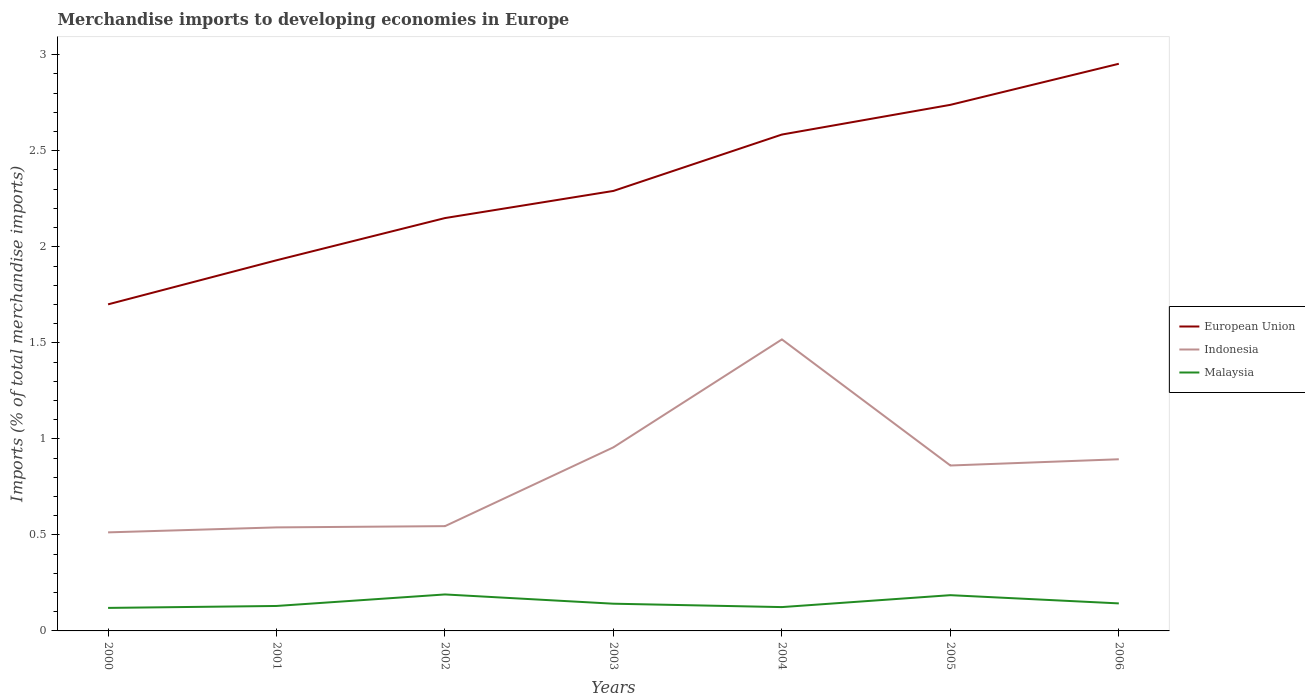How many different coloured lines are there?
Give a very brief answer. 3. Does the line corresponding to European Union intersect with the line corresponding to Malaysia?
Keep it short and to the point. No. Across all years, what is the maximum percentage total merchandise imports in European Union?
Provide a short and direct response. 1.7. In which year was the percentage total merchandise imports in Indonesia maximum?
Provide a short and direct response. 2000. What is the total percentage total merchandise imports in Malaysia in the graph?
Provide a short and direct response. -0. What is the difference between the highest and the second highest percentage total merchandise imports in Indonesia?
Your answer should be compact. 1. What is the difference between the highest and the lowest percentage total merchandise imports in European Union?
Provide a short and direct response. 3. How many lines are there?
Give a very brief answer. 3. How many years are there in the graph?
Make the answer very short. 7. Are the values on the major ticks of Y-axis written in scientific E-notation?
Offer a terse response. No. Does the graph contain any zero values?
Make the answer very short. No. Where does the legend appear in the graph?
Ensure brevity in your answer.  Center right. How are the legend labels stacked?
Keep it short and to the point. Vertical. What is the title of the graph?
Your answer should be very brief. Merchandise imports to developing economies in Europe. Does "Luxembourg" appear as one of the legend labels in the graph?
Provide a succinct answer. No. What is the label or title of the Y-axis?
Give a very brief answer. Imports (% of total merchandise imports). What is the Imports (% of total merchandise imports) of European Union in 2000?
Provide a succinct answer. 1.7. What is the Imports (% of total merchandise imports) of Indonesia in 2000?
Your answer should be very brief. 0.51. What is the Imports (% of total merchandise imports) in Malaysia in 2000?
Your answer should be very brief. 0.12. What is the Imports (% of total merchandise imports) of European Union in 2001?
Make the answer very short. 1.93. What is the Imports (% of total merchandise imports) of Indonesia in 2001?
Provide a short and direct response. 0.54. What is the Imports (% of total merchandise imports) of Malaysia in 2001?
Your response must be concise. 0.13. What is the Imports (% of total merchandise imports) of European Union in 2002?
Make the answer very short. 2.15. What is the Imports (% of total merchandise imports) in Indonesia in 2002?
Provide a short and direct response. 0.55. What is the Imports (% of total merchandise imports) in Malaysia in 2002?
Ensure brevity in your answer.  0.19. What is the Imports (% of total merchandise imports) in European Union in 2003?
Provide a short and direct response. 2.29. What is the Imports (% of total merchandise imports) of Indonesia in 2003?
Give a very brief answer. 0.96. What is the Imports (% of total merchandise imports) of Malaysia in 2003?
Ensure brevity in your answer.  0.14. What is the Imports (% of total merchandise imports) of European Union in 2004?
Give a very brief answer. 2.58. What is the Imports (% of total merchandise imports) in Indonesia in 2004?
Offer a very short reply. 1.52. What is the Imports (% of total merchandise imports) of Malaysia in 2004?
Offer a terse response. 0.12. What is the Imports (% of total merchandise imports) in European Union in 2005?
Your answer should be very brief. 2.74. What is the Imports (% of total merchandise imports) in Indonesia in 2005?
Provide a short and direct response. 0.86. What is the Imports (% of total merchandise imports) in Malaysia in 2005?
Ensure brevity in your answer.  0.19. What is the Imports (% of total merchandise imports) of European Union in 2006?
Make the answer very short. 2.95. What is the Imports (% of total merchandise imports) in Indonesia in 2006?
Your answer should be very brief. 0.89. What is the Imports (% of total merchandise imports) of Malaysia in 2006?
Ensure brevity in your answer.  0.14. Across all years, what is the maximum Imports (% of total merchandise imports) in European Union?
Your answer should be very brief. 2.95. Across all years, what is the maximum Imports (% of total merchandise imports) in Indonesia?
Give a very brief answer. 1.52. Across all years, what is the maximum Imports (% of total merchandise imports) of Malaysia?
Offer a very short reply. 0.19. Across all years, what is the minimum Imports (% of total merchandise imports) of European Union?
Give a very brief answer. 1.7. Across all years, what is the minimum Imports (% of total merchandise imports) in Indonesia?
Your answer should be compact. 0.51. Across all years, what is the minimum Imports (% of total merchandise imports) in Malaysia?
Give a very brief answer. 0.12. What is the total Imports (% of total merchandise imports) of European Union in the graph?
Your response must be concise. 16.35. What is the total Imports (% of total merchandise imports) of Indonesia in the graph?
Ensure brevity in your answer.  5.83. What is the total Imports (% of total merchandise imports) in Malaysia in the graph?
Give a very brief answer. 1.03. What is the difference between the Imports (% of total merchandise imports) in European Union in 2000 and that in 2001?
Your answer should be compact. -0.23. What is the difference between the Imports (% of total merchandise imports) of Indonesia in 2000 and that in 2001?
Provide a short and direct response. -0.03. What is the difference between the Imports (% of total merchandise imports) in Malaysia in 2000 and that in 2001?
Offer a very short reply. -0.01. What is the difference between the Imports (% of total merchandise imports) of European Union in 2000 and that in 2002?
Provide a succinct answer. -0.45. What is the difference between the Imports (% of total merchandise imports) of Indonesia in 2000 and that in 2002?
Your response must be concise. -0.03. What is the difference between the Imports (% of total merchandise imports) in Malaysia in 2000 and that in 2002?
Your answer should be very brief. -0.07. What is the difference between the Imports (% of total merchandise imports) in European Union in 2000 and that in 2003?
Offer a very short reply. -0.59. What is the difference between the Imports (% of total merchandise imports) in Indonesia in 2000 and that in 2003?
Ensure brevity in your answer.  -0.44. What is the difference between the Imports (% of total merchandise imports) of Malaysia in 2000 and that in 2003?
Make the answer very short. -0.02. What is the difference between the Imports (% of total merchandise imports) of European Union in 2000 and that in 2004?
Make the answer very short. -0.88. What is the difference between the Imports (% of total merchandise imports) of Indonesia in 2000 and that in 2004?
Ensure brevity in your answer.  -1. What is the difference between the Imports (% of total merchandise imports) of Malaysia in 2000 and that in 2004?
Your answer should be compact. -0. What is the difference between the Imports (% of total merchandise imports) of European Union in 2000 and that in 2005?
Make the answer very short. -1.04. What is the difference between the Imports (% of total merchandise imports) of Indonesia in 2000 and that in 2005?
Provide a short and direct response. -0.35. What is the difference between the Imports (% of total merchandise imports) of Malaysia in 2000 and that in 2005?
Offer a terse response. -0.07. What is the difference between the Imports (% of total merchandise imports) of European Union in 2000 and that in 2006?
Provide a succinct answer. -1.25. What is the difference between the Imports (% of total merchandise imports) in Indonesia in 2000 and that in 2006?
Ensure brevity in your answer.  -0.38. What is the difference between the Imports (% of total merchandise imports) of Malaysia in 2000 and that in 2006?
Give a very brief answer. -0.02. What is the difference between the Imports (% of total merchandise imports) of European Union in 2001 and that in 2002?
Ensure brevity in your answer.  -0.22. What is the difference between the Imports (% of total merchandise imports) of Indonesia in 2001 and that in 2002?
Offer a terse response. -0.01. What is the difference between the Imports (% of total merchandise imports) of Malaysia in 2001 and that in 2002?
Make the answer very short. -0.06. What is the difference between the Imports (% of total merchandise imports) in European Union in 2001 and that in 2003?
Ensure brevity in your answer.  -0.36. What is the difference between the Imports (% of total merchandise imports) of Indonesia in 2001 and that in 2003?
Offer a terse response. -0.42. What is the difference between the Imports (% of total merchandise imports) in Malaysia in 2001 and that in 2003?
Ensure brevity in your answer.  -0.01. What is the difference between the Imports (% of total merchandise imports) in European Union in 2001 and that in 2004?
Your answer should be very brief. -0.65. What is the difference between the Imports (% of total merchandise imports) of Indonesia in 2001 and that in 2004?
Give a very brief answer. -0.98. What is the difference between the Imports (% of total merchandise imports) of Malaysia in 2001 and that in 2004?
Offer a very short reply. 0.01. What is the difference between the Imports (% of total merchandise imports) in European Union in 2001 and that in 2005?
Offer a terse response. -0.81. What is the difference between the Imports (% of total merchandise imports) in Indonesia in 2001 and that in 2005?
Offer a very short reply. -0.32. What is the difference between the Imports (% of total merchandise imports) in Malaysia in 2001 and that in 2005?
Provide a succinct answer. -0.06. What is the difference between the Imports (% of total merchandise imports) of European Union in 2001 and that in 2006?
Offer a terse response. -1.02. What is the difference between the Imports (% of total merchandise imports) of Indonesia in 2001 and that in 2006?
Keep it short and to the point. -0.35. What is the difference between the Imports (% of total merchandise imports) of Malaysia in 2001 and that in 2006?
Offer a terse response. -0.01. What is the difference between the Imports (% of total merchandise imports) of European Union in 2002 and that in 2003?
Your response must be concise. -0.14. What is the difference between the Imports (% of total merchandise imports) of Indonesia in 2002 and that in 2003?
Provide a succinct answer. -0.41. What is the difference between the Imports (% of total merchandise imports) in Malaysia in 2002 and that in 2003?
Keep it short and to the point. 0.05. What is the difference between the Imports (% of total merchandise imports) in European Union in 2002 and that in 2004?
Your answer should be very brief. -0.43. What is the difference between the Imports (% of total merchandise imports) of Indonesia in 2002 and that in 2004?
Provide a succinct answer. -0.97. What is the difference between the Imports (% of total merchandise imports) in Malaysia in 2002 and that in 2004?
Ensure brevity in your answer.  0.07. What is the difference between the Imports (% of total merchandise imports) of European Union in 2002 and that in 2005?
Your response must be concise. -0.59. What is the difference between the Imports (% of total merchandise imports) in Indonesia in 2002 and that in 2005?
Ensure brevity in your answer.  -0.32. What is the difference between the Imports (% of total merchandise imports) of Malaysia in 2002 and that in 2005?
Your answer should be compact. 0. What is the difference between the Imports (% of total merchandise imports) of European Union in 2002 and that in 2006?
Your response must be concise. -0.8. What is the difference between the Imports (% of total merchandise imports) of Indonesia in 2002 and that in 2006?
Offer a very short reply. -0.35. What is the difference between the Imports (% of total merchandise imports) of Malaysia in 2002 and that in 2006?
Offer a very short reply. 0.05. What is the difference between the Imports (% of total merchandise imports) of European Union in 2003 and that in 2004?
Offer a very short reply. -0.29. What is the difference between the Imports (% of total merchandise imports) of Indonesia in 2003 and that in 2004?
Your response must be concise. -0.56. What is the difference between the Imports (% of total merchandise imports) of Malaysia in 2003 and that in 2004?
Ensure brevity in your answer.  0.02. What is the difference between the Imports (% of total merchandise imports) in European Union in 2003 and that in 2005?
Offer a very short reply. -0.45. What is the difference between the Imports (% of total merchandise imports) of Indonesia in 2003 and that in 2005?
Offer a terse response. 0.09. What is the difference between the Imports (% of total merchandise imports) in Malaysia in 2003 and that in 2005?
Keep it short and to the point. -0.04. What is the difference between the Imports (% of total merchandise imports) in European Union in 2003 and that in 2006?
Provide a succinct answer. -0.66. What is the difference between the Imports (% of total merchandise imports) in Indonesia in 2003 and that in 2006?
Give a very brief answer. 0.06. What is the difference between the Imports (% of total merchandise imports) of Malaysia in 2003 and that in 2006?
Keep it short and to the point. -0. What is the difference between the Imports (% of total merchandise imports) of European Union in 2004 and that in 2005?
Offer a very short reply. -0.15. What is the difference between the Imports (% of total merchandise imports) of Indonesia in 2004 and that in 2005?
Your answer should be compact. 0.66. What is the difference between the Imports (% of total merchandise imports) of Malaysia in 2004 and that in 2005?
Offer a very short reply. -0.06. What is the difference between the Imports (% of total merchandise imports) in European Union in 2004 and that in 2006?
Offer a terse response. -0.37. What is the difference between the Imports (% of total merchandise imports) of Indonesia in 2004 and that in 2006?
Offer a terse response. 0.62. What is the difference between the Imports (% of total merchandise imports) of Malaysia in 2004 and that in 2006?
Give a very brief answer. -0.02. What is the difference between the Imports (% of total merchandise imports) in European Union in 2005 and that in 2006?
Keep it short and to the point. -0.21. What is the difference between the Imports (% of total merchandise imports) in Indonesia in 2005 and that in 2006?
Your answer should be very brief. -0.03. What is the difference between the Imports (% of total merchandise imports) of Malaysia in 2005 and that in 2006?
Your response must be concise. 0.04. What is the difference between the Imports (% of total merchandise imports) of European Union in 2000 and the Imports (% of total merchandise imports) of Indonesia in 2001?
Ensure brevity in your answer.  1.16. What is the difference between the Imports (% of total merchandise imports) of European Union in 2000 and the Imports (% of total merchandise imports) of Malaysia in 2001?
Offer a very short reply. 1.57. What is the difference between the Imports (% of total merchandise imports) of Indonesia in 2000 and the Imports (% of total merchandise imports) of Malaysia in 2001?
Your answer should be very brief. 0.38. What is the difference between the Imports (% of total merchandise imports) of European Union in 2000 and the Imports (% of total merchandise imports) of Indonesia in 2002?
Offer a terse response. 1.15. What is the difference between the Imports (% of total merchandise imports) of European Union in 2000 and the Imports (% of total merchandise imports) of Malaysia in 2002?
Your response must be concise. 1.51. What is the difference between the Imports (% of total merchandise imports) in Indonesia in 2000 and the Imports (% of total merchandise imports) in Malaysia in 2002?
Provide a succinct answer. 0.32. What is the difference between the Imports (% of total merchandise imports) in European Union in 2000 and the Imports (% of total merchandise imports) in Indonesia in 2003?
Your response must be concise. 0.74. What is the difference between the Imports (% of total merchandise imports) in European Union in 2000 and the Imports (% of total merchandise imports) in Malaysia in 2003?
Your response must be concise. 1.56. What is the difference between the Imports (% of total merchandise imports) in Indonesia in 2000 and the Imports (% of total merchandise imports) in Malaysia in 2003?
Your answer should be very brief. 0.37. What is the difference between the Imports (% of total merchandise imports) of European Union in 2000 and the Imports (% of total merchandise imports) of Indonesia in 2004?
Your answer should be very brief. 0.18. What is the difference between the Imports (% of total merchandise imports) of European Union in 2000 and the Imports (% of total merchandise imports) of Malaysia in 2004?
Offer a very short reply. 1.58. What is the difference between the Imports (% of total merchandise imports) of Indonesia in 2000 and the Imports (% of total merchandise imports) of Malaysia in 2004?
Offer a terse response. 0.39. What is the difference between the Imports (% of total merchandise imports) of European Union in 2000 and the Imports (% of total merchandise imports) of Indonesia in 2005?
Offer a terse response. 0.84. What is the difference between the Imports (% of total merchandise imports) in European Union in 2000 and the Imports (% of total merchandise imports) in Malaysia in 2005?
Your response must be concise. 1.51. What is the difference between the Imports (% of total merchandise imports) in Indonesia in 2000 and the Imports (% of total merchandise imports) in Malaysia in 2005?
Your answer should be very brief. 0.33. What is the difference between the Imports (% of total merchandise imports) in European Union in 2000 and the Imports (% of total merchandise imports) in Indonesia in 2006?
Your response must be concise. 0.81. What is the difference between the Imports (% of total merchandise imports) of European Union in 2000 and the Imports (% of total merchandise imports) of Malaysia in 2006?
Give a very brief answer. 1.56. What is the difference between the Imports (% of total merchandise imports) of Indonesia in 2000 and the Imports (% of total merchandise imports) of Malaysia in 2006?
Provide a succinct answer. 0.37. What is the difference between the Imports (% of total merchandise imports) of European Union in 2001 and the Imports (% of total merchandise imports) of Indonesia in 2002?
Ensure brevity in your answer.  1.38. What is the difference between the Imports (% of total merchandise imports) in European Union in 2001 and the Imports (% of total merchandise imports) in Malaysia in 2002?
Give a very brief answer. 1.74. What is the difference between the Imports (% of total merchandise imports) in Indonesia in 2001 and the Imports (% of total merchandise imports) in Malaysia in 2002?
Your response must be concise. 0.35. What is the difference between the Imports (% of total merchandise imports) in European Union in 2001 and the Imports (% of total merchandise imports) in Indonesia in 2003?
Your answer should be compact. 0.97. What is the difference between the Imports (% of total merchandise imports) of European Union in 2001 and the Imports (% of total merchandise imports) of Malaysia in 2003?
Your response must be concise. 1.79. What is the difference between the Imports (% of total merchandise imports) of Indonesia in 2001 and the Imports (% of total merchandise imports) of Malaysia in 2003?
Your answer should be compact. 0.4. What is the difference between the Imports (% of total merchandise imports) of European Union in 2001 and the Imports (% of total merchandise imports) of Indonesia in 2004?
Keep it short and to the point. 0.41. What is the difference between the Imports (% of total merchandise imports) of European Union in 2001 and the Imports (% of total merchandise imports) of Malaysia in 2004?
Ensure brevity in your answer.  1.81. What is the difference between the Imports (% of total merchandise imports) of Indonesia in 2001 and the Imports (% of total merchandise imports) of Malaysia in 2004?
Your answer should be very brief. 0.41. What is the difference between the Imports (% of total merchandise imports) of European Union in 2001 and the Imports (% of total merchandise imports) of Indonesia in 2005?
Keep it short and to the point. 1.07. What is the difference between the Imports (% of total merchandise imports) of European Union in 2001 and the Imports (% of total merchandise imports) of Malaysia in 2005?
Keep it short and to the point. 1.74. What is the difference between the Imports (% of total merchandise imports) of Indonesia in 2001 and the Imports (% of total merchandise imports) of Malaysia in 2005?
Ensure brevity in your answer.  0.35. What is the difference between the Imports (% of total merchandise imports) of European Union in 2001 and the Imports (% of total merchandise imports) of Indonesia in 2006?
Your response must be concise. 1.04. What is the difference between the Imports (% of total merchandise imports) of European Union in 2001 and the Imports (% of total merchandise imports) of Malaysia in 2006?
Your answer should be compact. 1.79. What is the difference between the Imports (% of total merchandise imports) in Indonesia in 2001 and the Imports (% of total merchandise imports) in Malaysia in 2006?
Your answer should be very brief. 0.4. What is the difference between the Imports (% of total merchandise imports) in European Union in 2002 and the Imports (% of total merchandise imports) in Indonesia in 2003?
Make the answer very short. 1.19. What is the difference between the Imports (% of total merchandise imports) in European Union in 2002 and the Imports (% of total merchandise imports) in Malaysia in 2003?
Make the answer very short. 2.01. What is the difference between the Imports (% of total merchandise imports) in Indonesia in 2002 and the Imports (% of total merchandise imports) in Malaysia in 2003?
Provide a succinct answer. 0.4. What is the difference between the Imports (% of total merchandise imports) in European Union in 2002 and the Imports (% of total merchandise imports) in Indonesia in 2004?
Provide a succinct answer. 0.63. What is the difference between the Imports (% of total merchandise imports) of European Union in 2002 and the Imports (% of total merchandise imports) of Malaysia in 2004?
Offer a very short reply. 2.03. What is the difference between the Imports (% of total merchandise imports) of Indonesia in 2002 and the Imports (% of total merchandise imports) of Malaysia in 2004?
Give a very brief answer. 0.42. What is the difference between the Imports (% of total merchandise imports) of European Union in 2002 and the Imports (% of total merchandise imports) of Indonesia in 2005?
Provide a succinct answer. 1.29. What is the difference between the Imports (% of total merchandise imports) in European Union in 2002 and the Imports (% of total merchandise imports) in Malaysia in 2005?
Your response must be concise. 1.96. What is the difference between the Imports (% of total merchandise imports) in Indonesia in 2002 and the Imports (% of total merchandise imports) in Malaysia in 2005?
Provide a short and direct response. 0.36. What is the difference between the Imports (% of total merchandise imports) of European Union in 2002 and the Imports (% of total merchandise imports) of Indonesia in 2006?
Provide a succinct answer. 1.26. What is the difference between the Imports (% of total merchandise imports) in European Union in 2002 and the Imports (% of total merchandise imports) in Malaysia in 2006?
Offer a terse response. 2.01. What is the difference between the Imports (% of total merchandise imports) of Indonesia in 2002 and the Imports (% of total merchandise imports) of Malaysia in 2006?
Make the answer very short. 0.4. What is the difference between the Imports (% of total merchandise imports) in European Union in 2003 and the Imports (% of total merchandise imports) in Indonesia in 2004?
Offer a terse response. 0.77. What is the difference between the Imports (% of total merchandise imports) of European Union in 2003 and the Imports (% of total merchandise imports) of Malaysia in 2004?
Make the answer very short. 2.17. What is the difference between the Imports (% of total merchandise imports) of Indonesia in 2003 and the Imports (% of total merchandise imports) of Malaysia in 2004?
Your response must be concise. 0.83. What is the difference between the Imports (% of total merchandise imports) in European Union in 2003 and the Imports (% of total merchandise imports) in Indonesia in 2005?
Provide a short and direct response. 1.43. What is the difference between the Imports (% of total merchandise imports) of European Union in 2003 and the Imports (% of total merchandise imports) of Malaysia in 2005?
Your response must be concise. 2.1. What is the difference between the Imports (% of total merchandise imports) in Indonesia in 2003 and the Imports (% of total merchandise imports) in Malaysia in 2005?
Keep it short and to the point. 0.77. What is the difference between the Imports (% of total merchandise imports) of European Union in 2003 and the Imports (% of total merchandise imports) of Indonesia in 2006?
Provide a short and direct response. 1.4. What is the difference between the Imports (% of total merchandise imports) of European Union in 2003 and the Imports (% of total merchandise imports) of Malaysia in 2006?
Your response must be concise. 2.15. What is the difference between the Imports (% of total merchandise imports) in Indonesia in 2003 and the Imports (% of total merchandise imports) in Malaysia in 2006?
Provide a short and direct response. 0.81. What is the difference between the Imports (% of total merchandise imports) of European Union in 2004 and the Imports (% of total merchandise imports) of Indonesia in 2005?
Your answer should be compact. 1.72. What is the difference between the Imports (% of total merchandise imports) in European Union in 2004 and the Imports (% of total merchandise imports) in Malaysia in 2005?
Your answer should be compact. 2.4. What is the difference between the Imports (% of total merchandise imports) in Indonesia in 2004 and the Imports (% of total merchandise imports) in Malaysia in 2005?
Offer a very short reply. 1.33. What is the difference between the Imports (% of total merchandise imports) of European Union in 2004 and the Imports (% of total merchandise imports) of Indonesia in 2006?
Your response must be concise. 1.69. What is the difference between the Imports (% of total merchandise imports) of European Union in 2004 and the Imports (% of total merchandise imports) of Malaysia in 2006?
Keep it short and to the point. 2.44. What is the difference between the Imports (% of total merchandise imports) of Indonesia in 2004 and the Imports (% of total merchandise imports) of Malaysia in 2006?
Provide a short and direct response. 1.37. What is the difference between the Imports (% of total merchandise imports) in European Union in 2005 and the Imports (% of total merchandise imports) in Indonesia in 2006?
Ensure brevity in your answer.  1.85. What is the difference between the Imports (% of total merchandise imports) in European Union in 2005 and the Imports (% of total merchandise imports) in Malaysia in 2006?
Offer a very short reply. 2.6. What is the difference between the Imports (% of total merchandise imports) of Indonesia in 2005 and the Imports (% of total merchandise imports) of Malaysia in 2006?
Offer a very short reply. 0.72. What is the average Imports (% of total merchandise imports) in European Union per year?
Keep it short and to the point. 2.34. What is the average Imports (% of total merchandise imports) of Indonesia per year?
Your answer should be compact. 0.83. What is the average Imports (% of total merchandise imports) of Malaysia per year?
Provide a succinct answer. 0.15. In the year 2000, what is the difference between the Imports (% of total merchandise imports) in European Union and Imports (% of total merchandise imports) in Indonesia?
Offer a very short reply. 1.19. In the year 2000, what is the difference between the Imports (% of total merchandise imports) in European Union and Imports (% of total merchandise imports) in Malaysia?
Offer a terse response. 1.58. In the year 2000, what is the difference between the Imports (% of total merchandise imports) of Indonesia and Imports (% of total merchandise imports) of Malaysia?
Ensure brevity in your answer.  0.39. In the year 2001, what is the difference between the Imports (% of total merchandise imports) in European Union and Imports (% of total merchandise imports) in Indonesia?
Give a very brief answer. 1.39. In the year 2001, what is the difference between the Imports (% of total merchandise imports) of European Union and Imports (% of total merchandise imports) of Malaysia?
Your response must be concise. 1.8. In the year 2001, what is the difference between the Imports (% of total merchandise imports) of Indonesia and Imports (% of total merchandise imports) of Malaysia?
Give a very brief answer. 0.41. In the year 2002, what is the difference between the Imports (% of total merchandise imports) of European Union and Imports (% of total merchandise imports) of Indonesia?
Your answer should be compact. 1.6. In the year 2002, what is the difference between the Imports (% of total merchandise imports) of European Union and Imports (% of total merchandise imports) of Malaysia?
Your answer should be compact. 1.96. In the year 2002, what is the difference between the Imports (% of total merchandise imports) in Indonesia and Imports (% of total merchandise imports) in Malaysia?
Your answer should be very brief. 0.36. In the year 2003, what is the difference between the Imports (% of total merchandise imports) of European Union and Imports (% of total merchandise imports) of Indonesia?
Your answer should be very brief. 1.33. In the year 2003, what is the difference between the Imports (% of total merchandise imports) in European Union and Imports (% of total merchandise imports) in Malaysia?
Offer a very short reply. 2.15. In the year 2003, what is the difference between the Imports (% of total merchandise imports) of Indonesia and Imports (% of total merchandise imports) of Malaysia?
Offer a very short reply. 0.81. In the year 2004, what is the difference between the Imports (% of total merchandise imports) of European Union and Imports (% of total merchandise imports) of Indonesia?
Make the answer very short. 1.07. In the year 2004, what is the difference between the Imports (% of total merchandise imports) in European Union and Imports (% of total merchandise imports) in Malaysia?
Ensure brevity in your answer.  2.46. In the year 2004, what is the difference between the Imports (% of total merchandise imports) of Indonesia and Imports (% of total merchandise imports) of Malaysia?
Your answer should be compact. 1.39. In the year 2005, what is the difference between the Imports (% of total merchandise imports) of European Union and Imports (% of total merchandise imports) of Indonesia?
Provide a succinct answer. 1.88. In the year 2005, what is the difference between the Imports (% of total merchandise imports) in European Union and Imports (% of total merchandise imports) in Malaysia?
Offer a very short reply. 2.55. In the year 2005, what is the difference between the Imports (% of total merchandise imports) in Indonesia and Imports (% of total merchandise imports) in Malaysia?
Your response must be concise. 0.68. In the year 2006, what is the difference between the Imports (% of total merchandise imports) in European Union and Imports (% of total merchandise imports) in Indonesia?
Your answer should be compact. 2.06. In the year 2006, what is the difference between the Imports (% of total merchandise imports) of European Union and Imports (% of total merchandise imports) of Malaysia?
Offer a very short reply. 2.81. In the year 2006, what is the difference between the Imports (% of total merchandise imports) in Indonesia and Imports (% of total merchandise imports) in Malaysia?
Make the answer very short. 0.75. What is the ratio of the Imports (% of total merchandise imports) of European Union in 2000 to that in 2001?
Give a very brief answer. 0.88. What is the ratio of the Imports (% of total merchandise imports) of Malaysia in 2000 to that in 2001?
Keep it short and to the point. 0.92. What is the ratio of the Imports (% of total merchandise imports) in European Union in 2000 to that in 2002?
Your answer should be very brief. 0.79. What is the ratio of the Imports (% of total merchandise imports) of Indonesia in 2000 to that in 2002?
Offer a terse response. 0.94. What is the ratio of the Imports (% of total merchandise imports) of Malaysia in 2000 to that in 2002?
Your answer should be compact. 0.63. What is the ratio of the Imports (% of total merchandise imports) in European Union in 2000 to that in 2003?
Provide a succinct answer. 0.74. What is the ratio of the Imports (% of total merchandise imports) of Indonesia in 2000 to that in 2003?
Your answer should be compact. 0.54. What is the ratio of the Imports (% of total merchandise imports) in Malaysia in 2000 to that in 2003?
Provide a succinct answer. 0.85. What is the ratio of the Imports (% of total merchandise imports) of European Union in 2000 to that in 2004?
Your response must be concise. 0.66. What is the ratio of the Imports (% of total merchandise imports) in Indonesia in 2000 to that in 2004?
Give a very brief answer. 0.34. What is the ratio of the Imports (% of total merchandise imports) of Malaysia in 2000 to that in 2004?
Your response must be concise. 0.97. What is the ratio of the Imports (% of total merchandise imports) in European Union in 2000 to that in 2005?
Keep it short and to the point. 0.62. What is the ratio of the Imports (% of total merchandise imports) of Indonesia in 2000 to that in 2005?
Offer a very short reply. 0.6. What is the ratio of the Imports (% of total merchandise imports) of Malaysia in 2000 to that in 2005?
Provide a succinct answer. 0.64. What is the ratio of the Imports (% of total merchandise imports) of European Union in 2000 to that in 2006?
Your response must be concise. 0.58. What is the ratio of the Imports (% of total merchandise imports) in Indonesia in 2000 to that in 2006?
Provide a succinct answer. 0.57. What is the ratio of the Imports (% of total merchandise imports) in Malaysia in 2000 to that in 2006?
Give a very brief answer. 0.84. What is the ratio of the Imports (% of total merchandise imports) of European Union in 2001 to that in 2002?
Make the answer very short. 0.9. What is the ratio of the Imports (% of total merchandise imports) in Malaysia in 2001 to that in 2002?
Keep it short and to the point. 0.68. What is the ratio of the Imports (% of total merchandise imports) in European Union in 2001 to that in 2003?
Your response must be concise. 0.84. What is the ratio of the Imports (% of total merchandise imports) of Indonesia in 2001 to that in 2003?
Keep it short and to the point. 0.56. What is the ratio of the Imports (% of total merchandise imports) in Malaysia in 2001 to that in 2003?
Your answer should be compact. 0.92. What is the ratio of the Imports (% of total merchandise imports) of European Union in 2001 to that in 2004?
Ensure brevity in your answer.  0.75. What is the ratio of the Imports (% of total merchandise imports) in Indonesia in 2001 to that in 2004?
Provide a short and direct response. 0.36. What is the ratio of the Imports (% of total merchandise imports) of Malaysia in 2001 to that in 2004?
Give a very brief answer. 1.05. What is the ratio of the Imports (% of total merchandise imports) in European Union in 2001 to that in 2005?
Make the answer very short. 0.7. What is the ratio of the Imports (% of total merchandise imports) in Indonesia in 2001 to that in 2005?
Your answer should be very brief. 0.63. What is the ratio of the Imports (% of total merchandise imports) of Malaysia in 2001 to that in 2005?
Your answer should be very brief. 0.7. What is the ratio of the Imports (% of total merchandise imports) of European Union in 2001 to that in 2006?
Make the answer very short. 0.65. What is the ratio of the Imports (% of total merchandise imports) of Indonesia in 2001 to that in 2006?
Provide a short and direct response. 0.6. What is the ratio of the Imports (% of total merchandise imports) in Malaysia in 2001 to that in 2006?
Your answer should be compact. 0.91. What is the ratio of the Imports (% of total merchandise imports) in European Union in 2002 to that in 2003?
Keep it short and to the point. 0.94. What is the ratio of the Imports (% of total merchandise imports) in Indonesia in 2002 to that in 2003?
Give a very brief answer. 0.57. What is the ratio of the Imports (% of total merchandise imports) of Malaysia in 2002 to that in 2003?
Your response must be concise. 1.34. What is the ratio of the Imports (% of total merchandise imports) in European Union in 2002 to that in 2004?
Provide a short and direct response. 0.83. What is the ratio of the Imports (% of total merchandise imports) of Indonesia in 2002 to that in 2004?
Ensure brevity in your answer.  0.36. What is the ratio of the Imports (% of total merchandise imports) of Malaysia in 2002 to that in 2004?
Your answer should be very brief. 1.53. What is the ratio of the Imports (% of total merchandise imports) in European Union in 2002 to that in 2005?
Your answer should be compact. 0.78. What is the ratio of the Imports (% of total merchandise imports) of Indonesia in 2002 to that in 2005?
Your answer should be compact. 0.63. What is the ratio of the Imports (% of total merchandise imports) in Malaysia in 2002 to that in 2005?
Make the answer very short. 1.02. What is the ratio of the Imports (% of total merchandise imports) of European Union in 2002 to that in 2006?
Make the answer very short. 0.73. What is the ratio of the Imports (% of total merchandise imports) in Indonesia in 2002 to that in 2006?
Keep it short and to the point. 0.61. What is the ratio of the Imports (% of total merchandise imports) in Malaysia in 2002 to that in 2006?
Keep it short and to the point. 1.33. What is the ratio of the Imports (% of total merchandise imports) of European Union in 2003 to that in 2004?
Keep it short and to the point. 0.89. What is the ratio of the Imports (% of total merchandise imports) of Indonesia in 2003 to that in 2004?
Your response must be concise. 0.63. What is the ratio of the Imports (% of total merchandise imports) in Malaysia in 2003 to that in 2004?
Your answer should be very brief. 1.14. What is the ratio of the Imports (% of total merchandise imports) of European Union in 2003 to that in 2005?
Provide a short and direct response. 0.84. What is the ratio of the Imports (% of total merchandise imports) in Indonesia in 2003 to that in 2005?
Offer a very short reply. 1.11. What is the ratio of the Imports (% of total merchandise imports) in Malaysia in 2003 to that in 2005?
Your answer should be compact. 0.76. What is the ratio of the Imports (% of total merchandise imports) in European Union in 2003 to that in 2006?
Provide a short and direct response. 0.78. What is the ratio of the Imports (% of total merchandise imports) in Indonesia in 2003 to that in 2006?
Your answer should be compact. 1.07. What is the ratio of the Imports (% of total merchandise imports) in Malaysia in 2003 to that in 2006?
Provide a short and direct response. 0.99. What is the ratio of the Imports (% of total merchandise imports) in European Union in 2004 to that in 2005?
Your answer should be compact. 0.94. What is the ratio of the Imports (% of total merchandise imports) of Indonesia in 2004 to that in 2005?
Your response must be concise. 1.76. What is the ratio of the Imports (% of total merchandise imports) in Malaysia in 2004 to that in 2005?
Provide a short and direct response. 0.67. What is the ratio of the Imports (% of total merchandise imports) of European Union in 2004 to that in 2006?
Give a very brief answer. 0.88. What is the ratio of the Imports (% of total merchandise imports) of Indonesia in 2004 to that in 2006?
Make the answer very short. 1.7. What is the ratio of the Imports (% of total merchandise imports) of Malaysia in 2004 to that in 2006?
Ensure brevity in your answer.  0.87. What is the ratio of the Imports (% of total merchandise imports) in European Union in 2005 to that in 2006?
Provide a succinct answer. 0.93. What is the ratio of the Imports (% of total merchandise imports) of Indonesia in 2005 to that in 2006?
Give a very brief answer. 0.96. What is the ratio of the Imports (% of total merchandise imports) in Malaysia in 2005 to that in 2006?
Your answer should be compact. 1.3. What is the difference between the highest and the second highest Imports (% of total merchandise imports) of European Union?
Your answer should be compact. 0.21. What is the difference between the highest and the second highest Imports (% of total merchandise imports) in Indonesia?
Your response must be concise. 0.56. What is the difference between the highest and the second highest Imports (% of total merchandise imports) in Malaysia?
Your answer should be very brief. 0. What is the difference between the highest and the lowest Imports (% of total merchandise imports) in European Union?
Provide a succinct answer. 1.25. What is the difference between the highest and the lowest Imports (% of total merchandise imports) in Malaysia?
Provide a succinct answer. 0.07. 